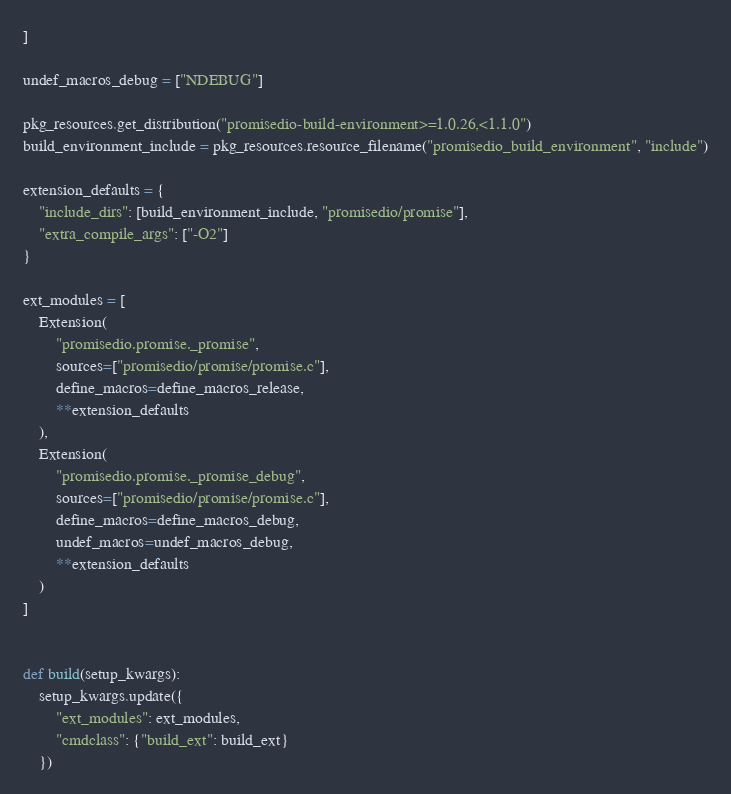Convert code to text. <code><loc_0><loc_0><loc_500><loc_500><_Python_>]

undef_macros_debug = ["NDEBUG"]

pkg_resources.get_distribution("promisedio-build-environment>=1.0.26,<1.1.0")
build_environment_include = pkg_resources.resource_filename("promisedio_build_environment", "include")

extension_defaults = {
    "include_dirs": [build_environment_include, "promisedio/promise"],
    "extra_compile_args": ["-O2"]
}

ext_modules = [
    Extension(
        "promisedio.promise._promise",
        sources=["promisedio/promise/promise.c"],
        define_macros=define_macros_release,
        **extension_defaults
    ),
    Extension(
        "promisedio.promise._promise_debug",
        sources=["promisedio/promise/promise.c"],
        define_macros=define_macros_debug,
        undef_macros=undef_macros_debug,
        **extension_defaults
    )
]


def build(setup_kwargs):
    setup_kwargs.update({
        "ext_modules": ext_modules,
        "cmdclass": {"build_ext": build_ext}
    })
</code> 